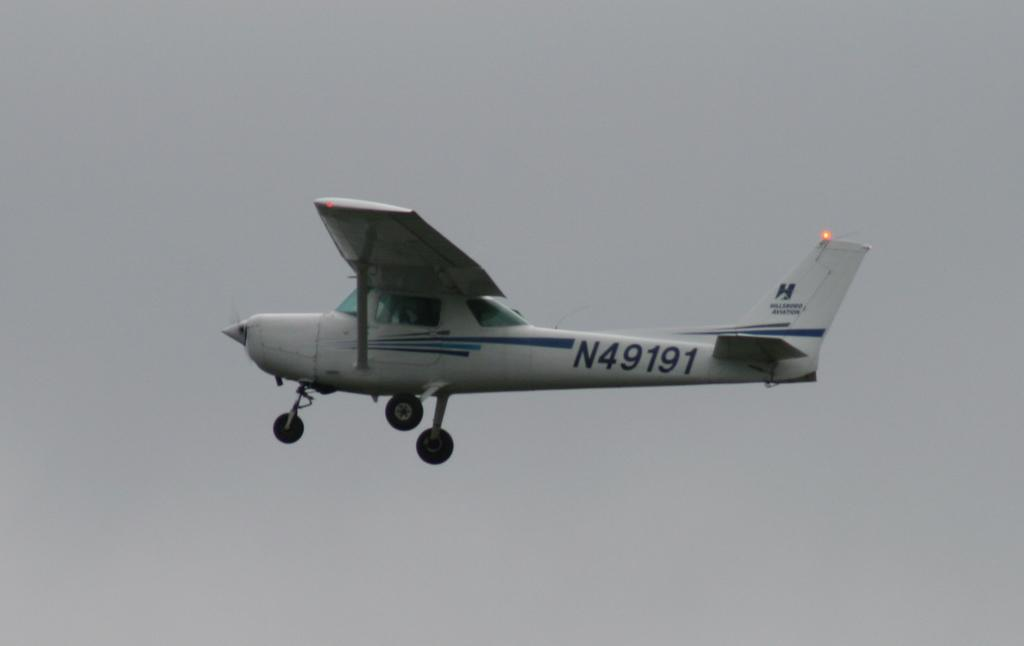What is the main subject of the picture? The main subject of the picture is an aircraft. What is the aircraft doing in the picture? The aircraft is flying in the sky. Where is the shop located in the image? There is no shop present in the image; it only features an aircraft flying in the sky. What type of tail is visible on the aircraft in the image? There is no specific tail type mentioned in the provided facts, and the image does not show enough detail to determine the tail type. 